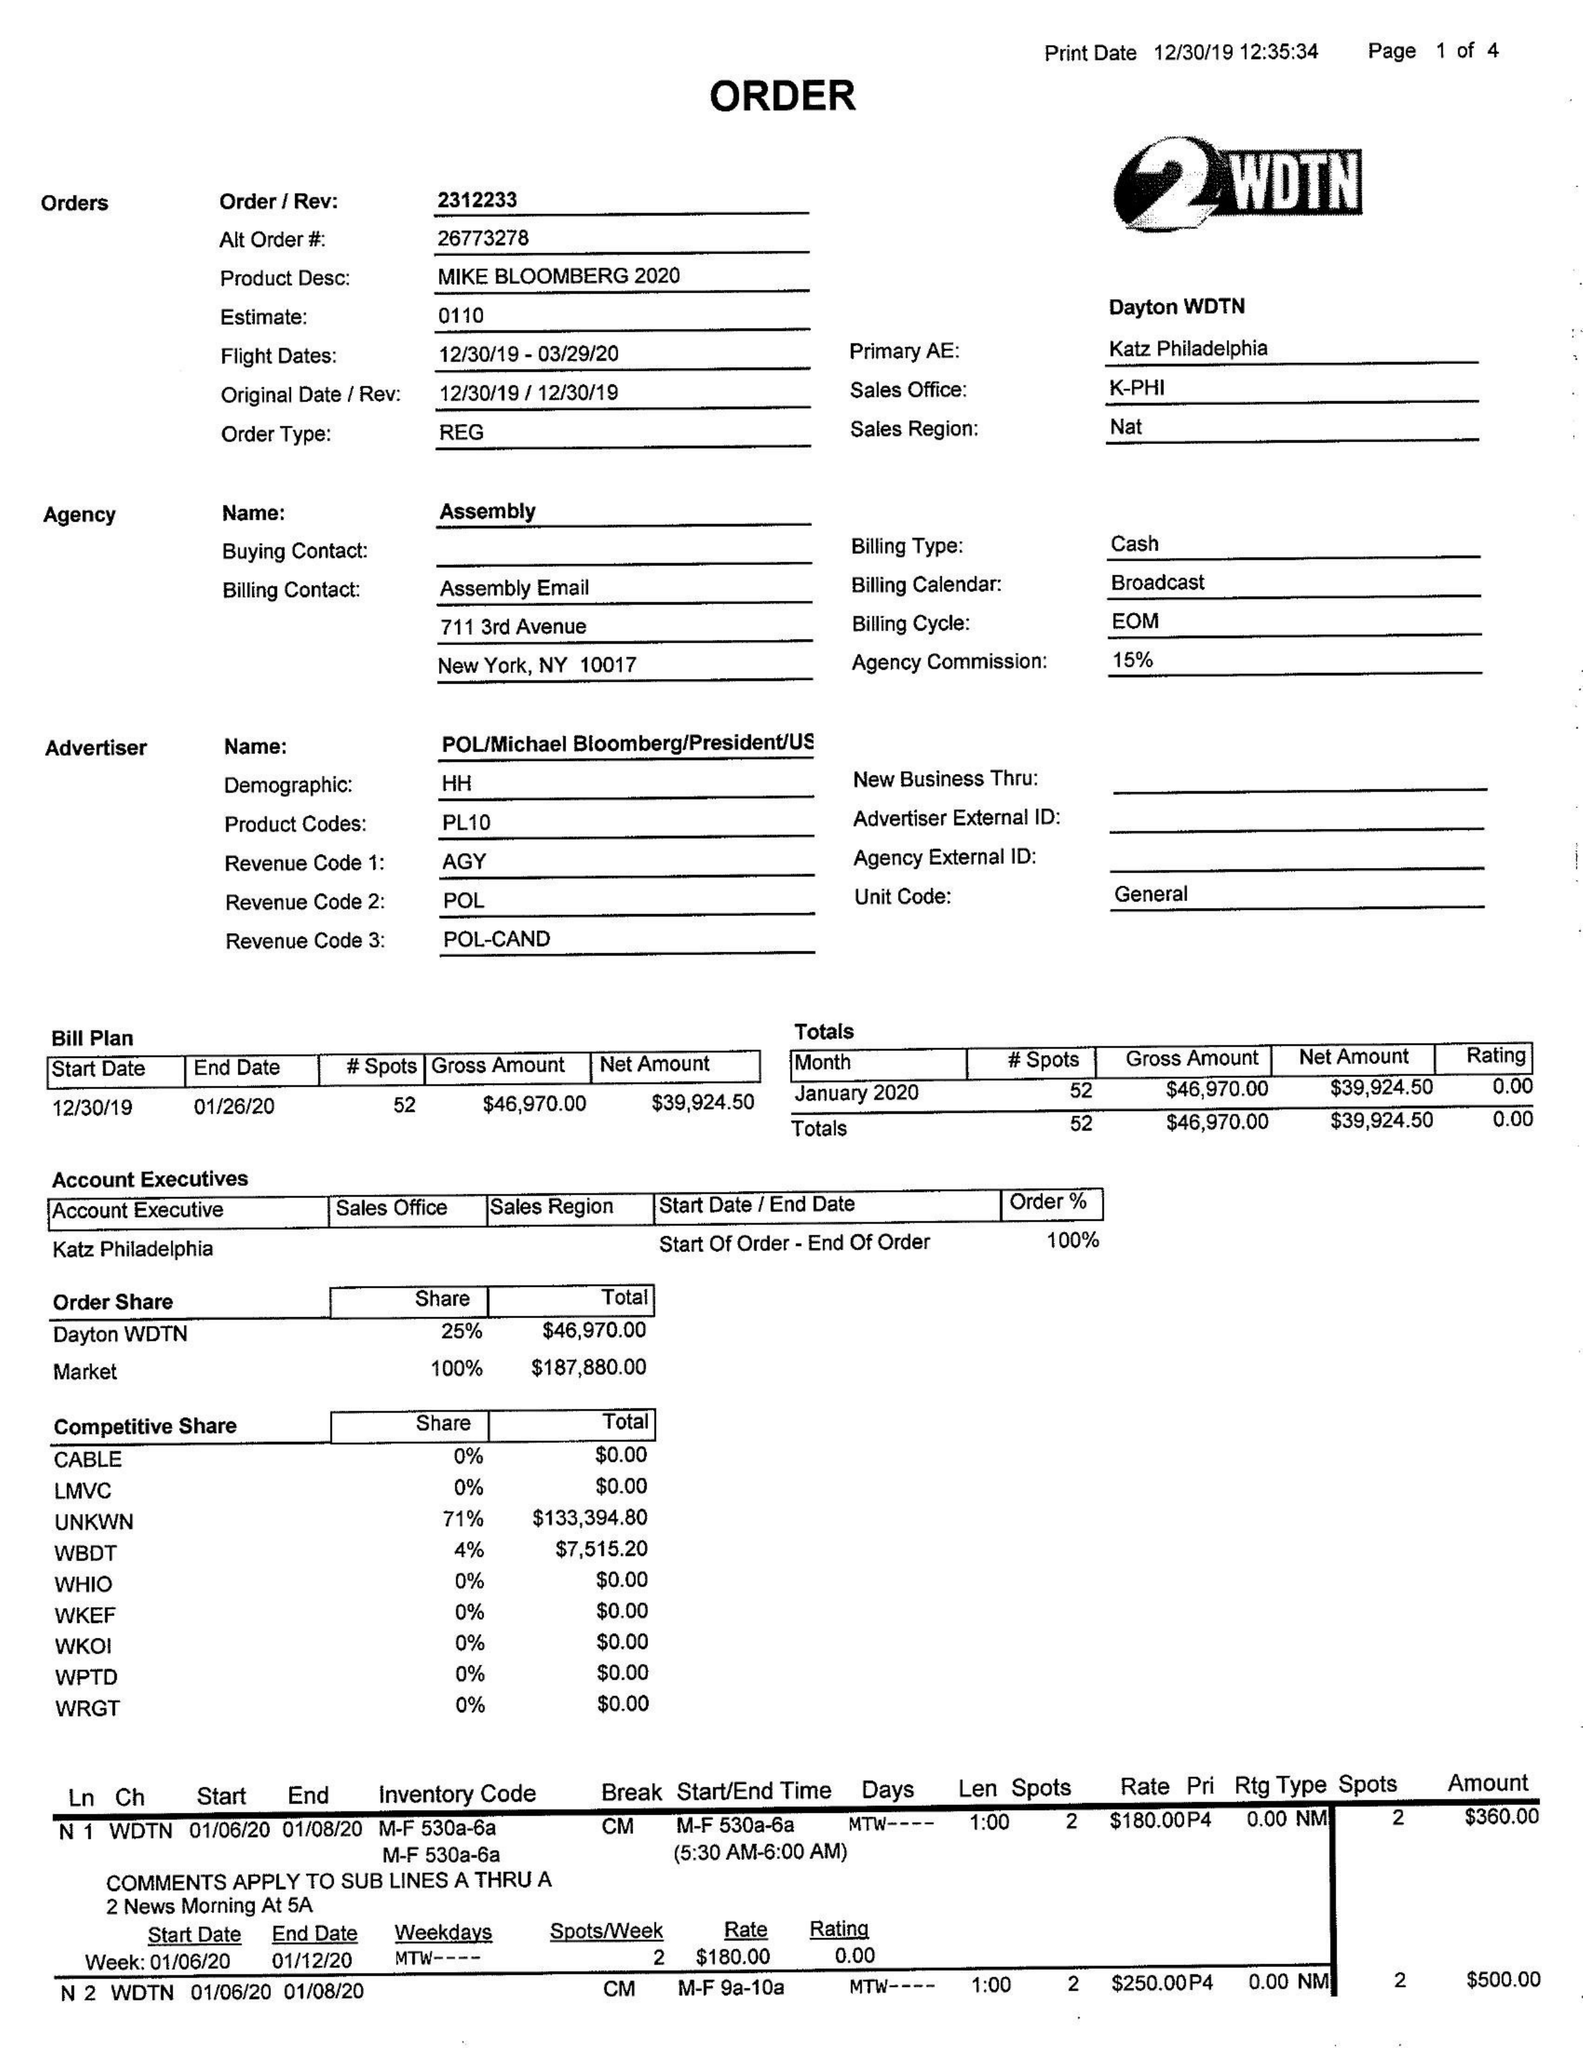What is the value for the contract_num?
Answer the question using a single word or phrase. 2312233 